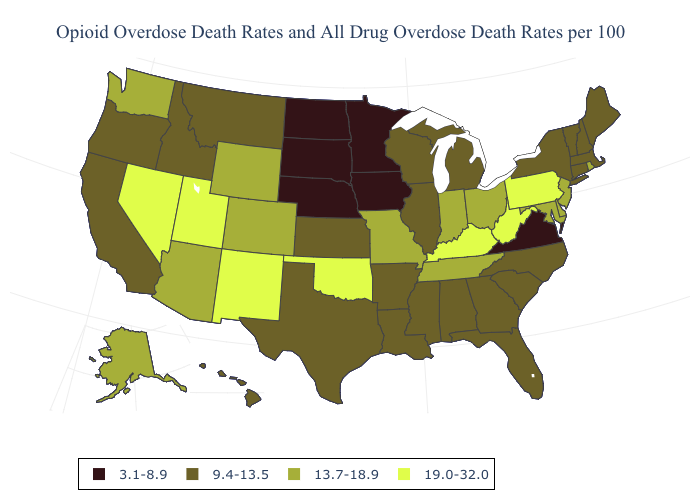Name the states that have a value in the range 3.1-8.9?
Concise answer only. Iowa, Minnesota, Nebraska, North Dakota, South Dakota, Virginia. Name the states that have a value in the range 19.0-32.0?
Be succinct. Kentucky, Nevada, New Mexico, Oklahoma, Pennsylvania, Utah, West Virginia. Name the states that have a value in the range 13.7-18.9?
Be succinct. Alaska, Arizona, Colorado, Delaware, Indiana, Maryland, Missouri, New Jersey, Ohio, Rhode Island, Tennessee, Washington, Wyoming. Which states have the lowest value in the USA?
Be succinct. Iowa, Minnesota, Nebraska, North Dakota, South Dakota, Virginia. Name the states that have a value in the range 13.7-18.9?
Concise answer only. Alaska, Arizona, Colorado, Delaware, Indiana, Maryland, Missouri, New Jersey, Ohio, Rhode Island, Tennessee, Washington, Wyoming. Does South Dakota have the same value as Missouri?
Quick response, please. No. Does New York have a higher value than Kentucky?
Short answer required. No. Does Alabama have the lowest value in the South?
Write a very short answer. No. Name the states that have a value in the range 3.1-8.9?
Be succinct. Iowa, Minnesota, Nebraska, North Dakota, South Dakota, Virginia. What is the lowest value in states that border New Hampshire?
Quick response, please. 9.4-13.5. Name the states that have a value in the range 3.1-8.9?
Short answer required. Iowa, Minnesota, Nebraska, North Dakota, South Dakota, Virginia. What is the value of Connecticut?
Answer briefly. 9.4-13.5. Which states have the lowest value in the USA?
Keep it brief. Iowa, Minnesota, Nebraska, North Dakota, South Dakota, Virginia. Among the states that border Virginia , which have the lowest value?
Write a very short answer. North Carolina. What is the highest value in states that border Alabama?
Quick response, please. 13.7-18.9. 